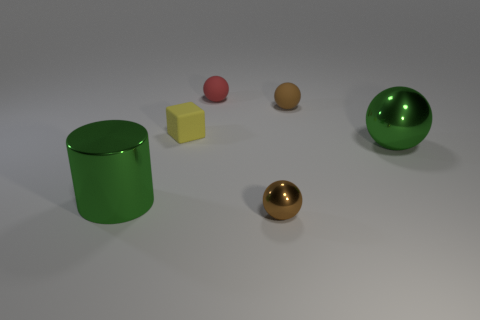Subtract all blue spheres. Subtract all purple blocks. How many spheres are left? 4 Add 1 small red rubber balls. How many objects exist? 7 Subtract all balls. How many objects are left? 2 Subtract all big green shiny cylinders. Subtract all large green objects. How many objects are left? 3 Add 1 brown rubber spheres. How many brown rubber spheres are left? 2 Add 1 cyan shiny cylinders. How many cyan shiny cylinders exist? 1 Subtract 0 gray blocks. How many objects are left? 6 